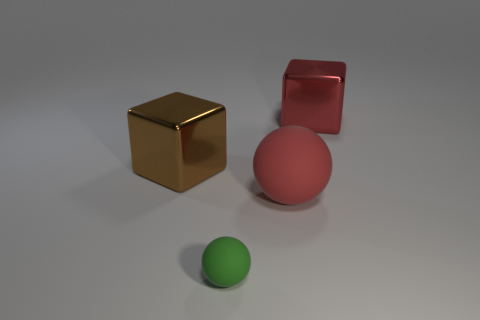There is a small thing that is the same shape as the big rubber thing; what is its material?
Ensure brevity in your answer.  Rubber. How many green metal things are the same size as the red metallic thing?
Your answer should be very brief. 0. There is a small thing that is the same material as the red ball; what is its color?
Make the answer very short. Green. Are there fewer green things than large green matte cylinders?
Ensure brevity in your answer.  No. How many red things are metal things or large balls?
Give a very brief answer. 2. What number of things are both to the right of the big brown metallic object and behind the green rubber thing?
Make the answer very short. 2. Do the brown cube and the small green sphere have the same material?
Your answer should be very brief. No. What shape is the matte object that is the same size as the red block?
Your response must be concise. Sphere. Are there more brown blocks than big blue rubber balls?
Your answer should be compact. Yes. What is the large object that is behind the large matte object and in front of the large red metallic cube made of?
Keep it short and to the point. Metal. 